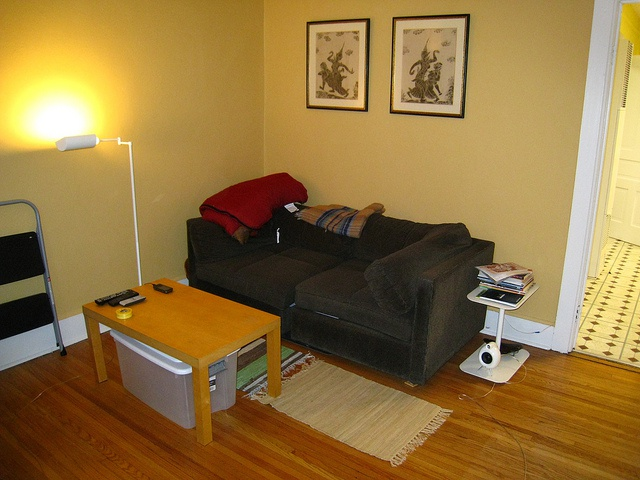Describe the objects in this image and their specific colors. I can see couch in olive, black, and tan tones, chair in olive, black, and gray tones, book in olive, black, tan, gray, and darkgray tones, book in olive, gray, tan, and darkgray tones, and book in olive, black, white, darkgray, and gray tones in this image. 